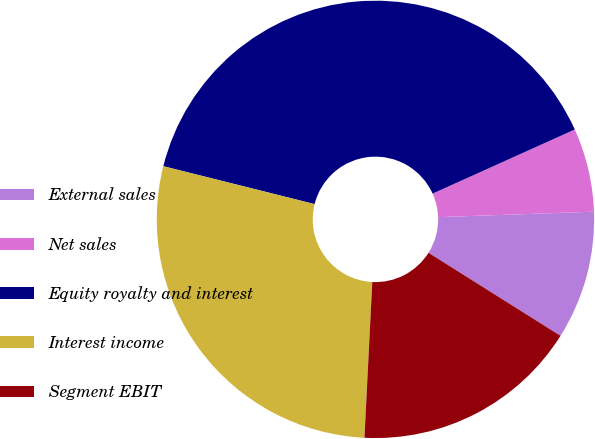<chart> <loc_0><loc_0><loc_500><loc_500><pie_chart><fcel>External sales<fcel>Net sales<fcel>Equity royalty and interest<fcel>Interest income<fcel>Segment EBIT<nl><fcel>9.5%<fcel>6.18%<fcel>39.35%<fcel>28.11%<fcel>16.86%<nl></chart> 